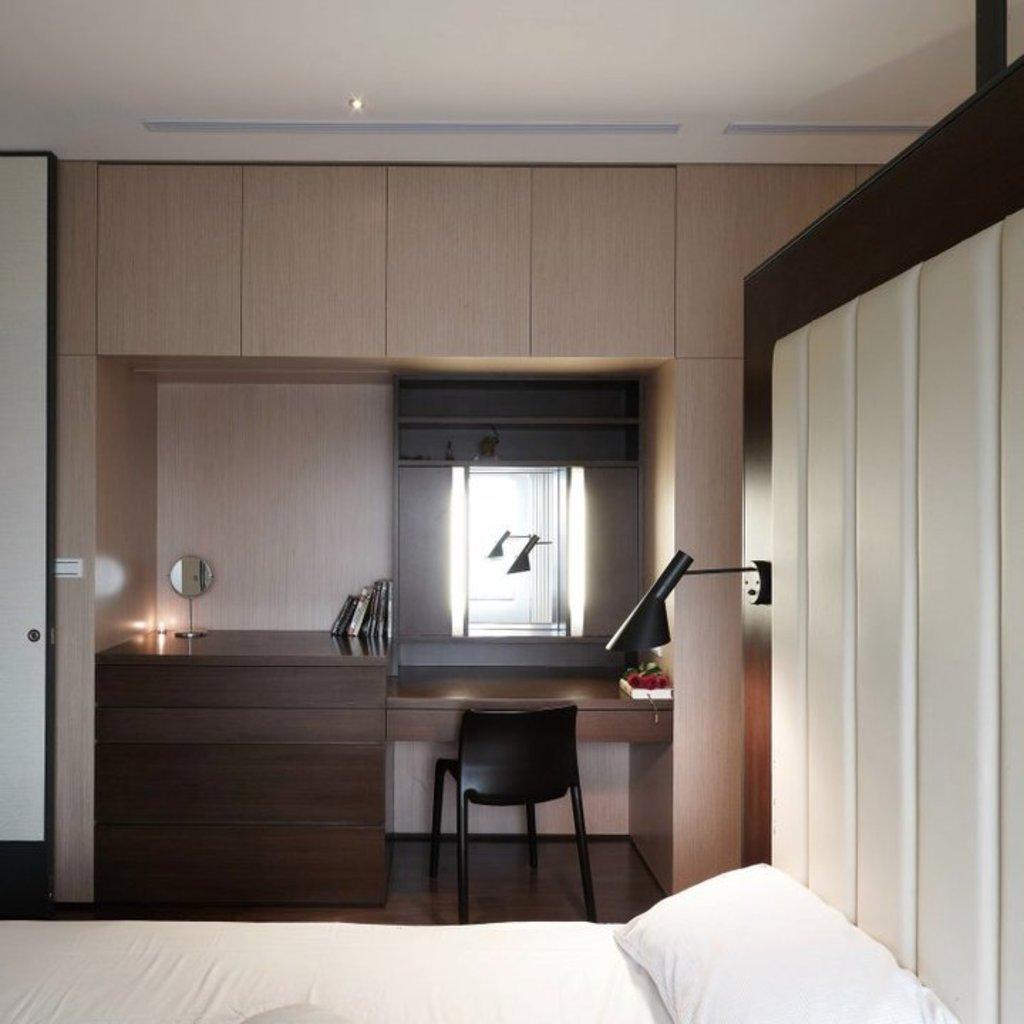In one or two sentences, can you explain what this image depicts? In this image there is an interior view of the room where there are pillows, a bed, a cupboard, a bed light, a door, a reflection of bed light in the mirror, there are books and a small mirror on the desk. 